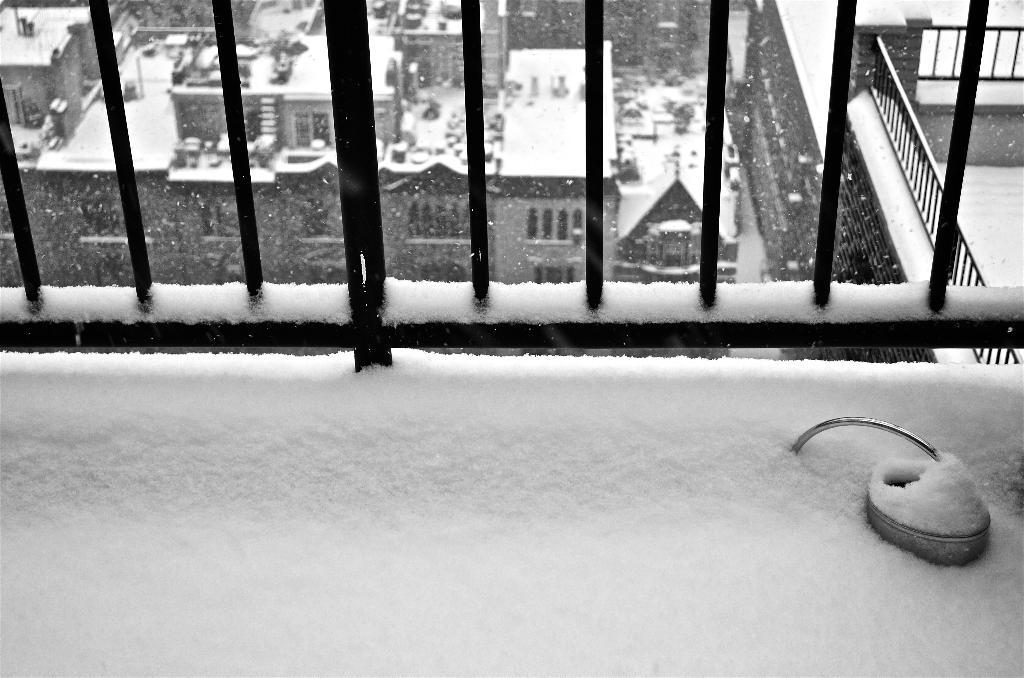What type of weather is depicted in the image? There is snow in the image, indicating a cold or wintry scene. What objects can be seen sticking out of the snow? There are metal rods in the image. What structures are visible in the background? There are buildings in the image. What color scheme is used in the image? The image is in black and white. What type of music can be heard playing in the background of the image? There is no music present in the image, as it is a still photograph. Can you see any planes flying in the sky in the image? There are no planes visible in the image; it only shows snow, metal rods, and buildings. 